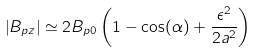Convert formula to latex. <formula><loc_0><loc_0><loc_500><loc_500>\left | B _ { p z } \right | \simeq 2 B _ { p 0 } \left ( 1 - \cos ( \alpha ) + \frac { \epsilon ^ { 2 } } { 2 a ^ { 2 } } \right )</formula> 